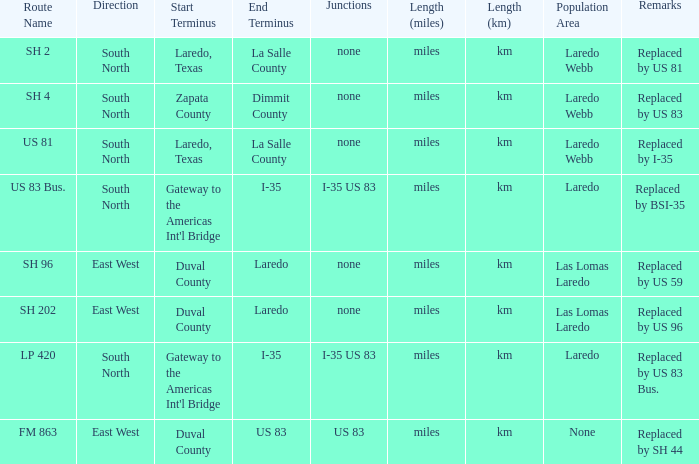Which junctions have "replaced by bsi-35" listed in their remarks section? I-35 US 83. 